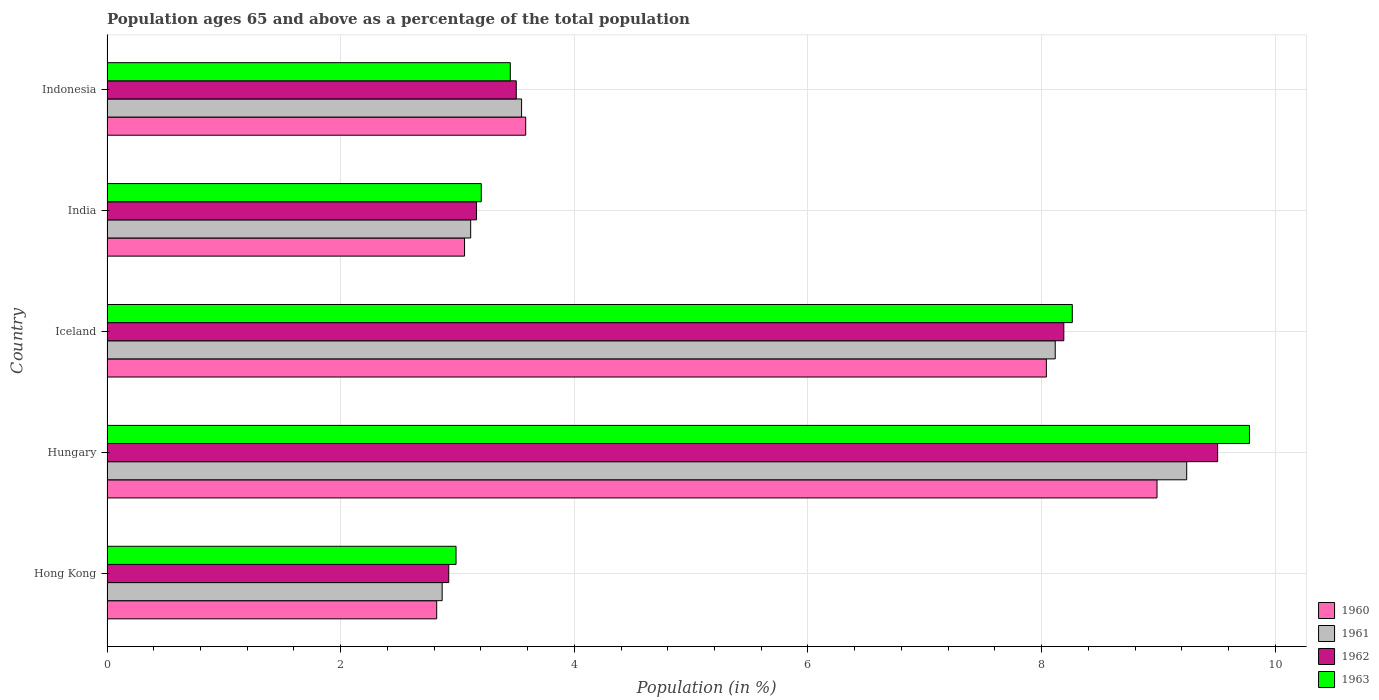How many different coloured bars are there?
Offer a very short reply. 4. How many groups of bars are there?
Your answer should be very brief. 5. Are the number of bars per tick equal to the number of legend labels?
Your answer should be compact. Yes. What is the label of the 5th group of bars from the top?
Offer a terse response. Hong Kong. What is the percentage of the population ages 65 and above in 1962 in India?
Your answer should be very brief. 3.16. Across all countries, what is the maximum percentage of the population ages 65 and above in 1961?
Provide a short and direct response. 9.24. Across all countries, what is the minimum percentage of the population ages 65 and above in 1962?
Give a very brief answer. 2.93. In which country was the percentage of the population ages 65 and above in 1960 maximum?
Make the answer very short. Hungary. In which country was the percentage of the population ages 65 and above in 1962 minimum?
Your answer should be very brief. Hong Kong. What is the total percentage of the population ages 65 and above in 1963 in the graph?
Your response must be concise. 27.69. What is the difference between the percentage of the population ages 65 and above in 1962 in Hong Kong and that in India?
Offer a very short reply. -0.24. What is the difference between the percentage of the population ages 65 and above in 1961 in India and the percentage of the population ages 65 and above in 1963 in Hungary?
Your response must be concise. -6.67. What is the average percentage of the population ages 65 and above in 1963 per country?
Make the answer very short. 5.54. What is the difference between the percentage of the population ages 65 and above in 1963 and percentage of the population ages 65 and above in 1962 in Iceland?
Make the answer very short. 0.07. In how many countries, is the percentage of the population ages 65 and above in 1962 greater than 5.6 ?
Your answer should be compact. 2. What is the ratio of the percentage of the population ages 65 and above in 1962 in Iceland to that in Indonesia?
Ensure brevity in your answer.  2.34. What is the difference between the highest and the second highest percentage of the population ages 65 and above in 1963?
Provide a succinct answer. 1.52. What is the difference between the highest and the lowest percentage of the population ages 65 and above in 1960?
Your answer should be compact. 6.17. In how many countries, is the percentage of the population ages 65 and above in 1962 greater than the average percentage of the population ages 65 and above in 1962 taken over all countries?
Provide a short and direct response. 2. How many bars are there?
Ensure brevity in your answer.  20. Are all the bars in the graph horizontal?
Give a very brief answer. Yes. How many countries are there in the graph?
Your answer should be very brief. 5. What is the difference between two consecutive major ticks on the X-axis?
Give a very brief answer. 2. Are the values on the major ticks of X-axis written in scientific E-notation?
Keep it short and to the point. No. Where does the legend appear in the graph?
Provide a succinct answer. Bottom right. How many legend labels are there?
Ensure brevity in your answer.  4. What is the title of the graph?
Give a very brief answer. Population ages 65 and above as a percentage of the total population. Does "1985" appear as one of the legend labels in the graph?
Provide a short and direct response. No. What is the label or title of the X-axis?
Keep it short and to the point. Population (in %). What is the Population (in %) in 1960 in Hong Kong?
Your answer should be very brief. 2.82. What is the Population (in %) of 1961 in Hong Kong?
Provide a succinct answer. 2.87. What is the Population (in %) in 1962 in Hong Kong?
Offer a very short reply. 2.93. What is the Population (in %) of 1963 in Hong Kong?
Offer a very short reply. 2.99. What is the Population (in %) of 1960 in Hungary?
Provide a short and direct response. 8.99. What is the Population (in %) in 1961 in Hungary?
Offer a very short reply. 9.24. What is the Population (in %) in 1962 in Hungary?
Ensure brevity in your answer.  9.51. What is the Population (in %) in 1963 in Hungary?
Your response must be concise. 9.78. What is the Population (in %) in 1960 in Iceland?
Provide a succinct answer. 8.04. What is the Population (in %) in 1961 in Iceland?
Ensure brevity in your answer.  8.12. What is the Population (in %) in 1962 in Iceland?
Provide a succinct answer. 8.19. What is the Population (in %) of 1963 in Iceland?
Offer a terse response. 8.26. What is the Population (in %) of 1960 in India?
Provide a short and direct response. 3.06. What is the Population (in %) of 1961 in India?
Give a very brief answer. 3.11. What is the Population (in %) in 1962 in India?
Your answer should be very brief. 3.16. What is the Population (in %) of 1963 in India?
Offer a very short reply. 3.2. What is the Population (in %) of 1960 in Indonesia?
Your response must be concise. 3.58. What is the Population (in %) in 1961 in Indonesia?
Offer a terse response. 3.55. What is the Population (in %) of 1962 in Indonesia?
Provide a succinct answer. 3.5. What is the Population (in %) of 1963 in Indonesia?
Offer a very short reply. 3.45. Across all countries, what is the maximum Population (in %) of 1960?
Offer a very short reply. 8.99. Across all countries, what is the maximum Population (in %) of 1961?
Provide a succinct answer. 9.24. Across all countries, what is the maximum Population (in %) in 1962?
Keep it short and to the point. 9.51. Across all countries, what is the maximum Population (in %) of 1963?
Give a very brief answer. 9.78. Across all countries, what is the minimum Population (in %) in 1960?
Your response must be concise. 2.82. Across all countries, what is the minimum Population (in %) in 1961?
Provide a succinct answer. 2.87. Across all countries, what is the minimum Population (in %) in 1962?
Offer a very short reply. 2.93. Across all countries, what is the minimum Population (in %) of 1963?
Offer a very short reply. 2.99. What is the total Population (in %) of 1960 in the graph?
Offer a very short reply. 26.5. What is the total Population (in %) in 1961 in the graph?
Provide a short and direct response. 26.89. What is the total Population (in %) in 1962 in the graph?
Offer a very short reply. 27.29. What is the total Population (in %) in 1963 in the graph?
Offer a very short reply. 27.69. What is the difference between the Population (in %) in 1960 in Hong Kong and that in Hungary?
Provide a succinct answer. -6.17. What is the difference between the Population (in %) in 1961 in Hong Kong and that in Hungary?
Your answer should be very brief. -6.37. What is the difference between the Population (in %) of 1962 in Hong Kong and that in Hungary?
Your response must be concise. -6.58. What is the difference between the Population (in %) of 1963 in Hong Kong and that in Hungary?
Offer a terse response. -6.79. What is the difference between the Population (in %) in 1960 in Hong Kong and that in Iceland?
Your response must be concise. -5.22. What is the difference between the Population (in %) in 1961 in Hong Kong and that in Iceland?
Ensure brevity in your answer.  -5.25. What is the difference between the Population (in %) of 1962 in Hong Kong and that in Iceland?
Your answer should be compact. -5.27. What is the difference between the Population (in %) in 1963 in Hong Kong and that in Iceland?
Your answer should be compact. -5.28. What is the difference between the Population (in %) in 1960 in Hong Kong and that in India?
Your answer should be very brief. -0.24. What is the difference between the Population (in %) of 1961 in Hong Kong and that in India?
Ensure brevity in your answer.  -0.24. What is the difference between the Population (in %) in 1962 in Hong Kong and that in India?
Your answer should be compact. -0.24. What is the difference between the Population (in %) of 1963 in Hong Kong and that in India?
Give a very brief answer. -0.22. What is the difference between the Population (in %) of 1960 in Hong Kong and that in Indonesia?
Offer a terse response. -0.76. What is the difference between the Population (in %) in 1961 in Hong Kong and that in Indonesia?
Offer a very short reply. -0.68. What is the difference between the Population (in %) of 1962 in Hong Kong and that in Indonesia?
Provide a short and direct response. -0.58. What is the difference between the Population (in %) in 1963 in Hong Kong and that in Indonesia?
Offer a very short reply. -0.46. What is the difference between the Population (in %) of 1960 in Hungary and that in Iceland?
Offer a very short reply. 0.95. What is the difference between the Population (in %) of 1961 in Hungary and that in Iceland?
Keep it short and to the point. 1.13. What is the difference between the Population (in %) in 1962 in Hungary and that in Iceland?
Your answer should be compact. 1.32. What is the difference between the Population (in %) in 1963 in Hungary and that in Iceland?
Offer a very short reply. 1.52. What is the difference between the Population (in %) in 1960 in Hungary and that in India?
Your response must be concise. 5.93. What is the difference between the Population (in %) of 1961 in Hungary and that in India?
Provide a short and direct response. 6.13. What is the difference between the Population (in %) of 1962 in Hungary and that in India?
Your response must be concise. 6.34. What is the difference between the Population (in %) of 1963 in Hungary and that in India?
Offer a terse response. 6.58. What is the difference between the Population (in %) in 1960 in Hungary and that in Indonesia?
Make the answer very short. 5.4. What is the difference between the Population (in %) in 1961 in Hungary and that in Indonesia?
Ensure brevity in your answer.  5.69. What is the difference between the Population (in %) of 1962 in Hungary and that in Indonesia?
Offer a terse response. 6. What is the difference between the Population (in %) in 1963 in Hungary and that in Indonesia?
Your answer should be very brief. 6.33. What is the difference between the Population (in %) of 1960 in Iceland and that in India?
Offer a very short reply. 4.98. What is the difference between the Population (in %) of 1961 in Iceland and that in India?
Give a very brief answer. 5. What is the difference between the Population (in %) in 1962 in Iceland and that in India?
Your response must be concise. 5.03. What is the difference between the Population (in %) of 1963 in Iceland and that in India?
Provide a short and direct response. 5.06. What is the difference between the Population (in %) of 1960 in Iceland and that in Indonesia?
Offer a terse response. 4.46. What is the difference between the Population (in %) in 1961 in Iceland and that in Indonesia?
Make the answer very short. 4.57. What is the difference between the Population (in %) in 1962 in Iceland and that in Indonesia?
Make the answer very short. 4.69. What is the difference between the Population (in %) in 1963 in Iceland and that in Indonesia?
Offer a terse response. 4.81. What is the difference between the Population (in %) in 1960 in India and that in Indonesia?
Provide a succinct answer. -0.52. What is the difference between the Population (in %) of 1961 in India and that in Indonesia?
Keep it short and to the point. -0.44. What is the difference between the Population (in %) of 1962 in India and that in Indonesia?
Keep it short and to the point. -0.34. What is the difference between the Population (in %) of 1963 in India and that in Indonesia?
Provide a succinct answer. -0.25. What is the difference between the Population (in %) in 1960 in Hong Kong and the Population (in %) in 1961 in Hungary?
Your answer should be very brief. -6.42. What is the difference between the Population (in %) in 1960 in Hong Kong and the Population (in %) in 1962 in Hungary?
Provide a succinct answer. -6.69. What is the difference between the Population (in %) of 1960 in Hong Kong and the Population (in %) of 1963 in Hungary?
Give a very brief answer. -6.96. What is the difference between the Population (in %) in 1961 in Hong Kong and the Population (in %) in 1962 in Hungary?
Give a very brief answer. -6.64. What is the difference between the Population (in %) in 1961 in Hong Kong and the Population (in %) in 1963 in Hungary?
Your answer should be very brief. -6.91. What is the difference between the Population (in %) in 1962 in Hong Kong and the Population (in %) in 1963 in Hungary?
Keep it short and to the point. -6.85. What is the difference between the Population (in %) of 1960 in Hong Kong and the Population (in %) of 1961 in Iceland?
Ensure brevity in your answer.  -5.29. What is the difference between the Population (in %) of 1960 in Hong Kong and the Population (in %) of 1962 in Iceland?
Keep it short and to the point. -5.37. What is the difference between the Population (in %) in 1960 in Hong Kong and the Population (in %) in 1963 in Iceland?
Provide a short and direct response. -5.44. What is the difference between the Population (in %) in 1961 in Hong Kong and the Population (in %) in 1962 in Iceland?
Your answer should be compact. -5.32. What is the difference between the Population (in %) in 1961 in Hong Kong and the Population (in %) in 1963 in Iceland?
Offer a very short reply. -5.39. What is the difference between the Population (in %) in 1962 in Hong Kong and the Population (in %) in 1963 in Iceland?
Give a very brief answer. -5.34. What is the difference between the Population (in %) in 1960 in Hong Kong and the Population (in %) in 1961 in India?
Make the answer very short. -0.29. What is the difference between the Population (in %) in 1960 in Hong Kong and the Population (in %) in 1962 in India?
Offer a terse response. -0.34. What is the difference between the Population (in %) in 1960 in Hong Kong and the Population (in %) in 1963 in India?
Offer a very short reply. -0.38. What is the difference between the Population (in %) in 1961 in Hong Kong and the Population (in %) in 1962 in India?
Provide a short and direct response. -0.29. What is the difference between the Population (in %) of 1961 in Hong Kong and the Population (in %) of 1963 in India?
Make the answer very short. -0.33. What is the difference between the Population (in %) in 1962 in Hong Kong and the Population (in %) in 1963 in India?
Provide a short and direct response. -0.28. What is the difference between the Population (in %) of 1960 in Hong Kong and the Population (in %) of 1961 in Indonesia?
Provide a succinct answer. -0.73. What is the difference between the Population (in %) in 1960 in Hong Kong and the Population (in %) in 1962 in Indonesia?
Provide a short and direct response. -0.68. What is the difference between the Population (in %) of 1960 in Hong Kong and the Population (in %) of 1963 in Indonesia?
Offer a terse response. -0.63. What is the difference between the Population (in %) of 1961 in Hong Kong and the Population (in %) of 1962 in Indonesia?
Your answer should be very brief. -0.63. What is the difference between the Population (in %) in 1961 in Hong Kong and the Population (in %) in 1963 in Indonesia?
Offer a very short reply. -0.58. What is the difference between the Population (in %) of 1962 in Hong Kong and the Population (in %) of 1963 in Indonesia?
Your answer should be very brief. -0.53. What is the difference between the Population (in %) in 1960 in Hungary and the Population (in %) in 1961 in Iceland?
Offer a very short reply. 0.87. What is the difference between the Population (in %) of 1960 in Hungary and the Population (in %) of 1962 in Iceland?
Offer a very short reply. 0.8. What is the difference between the Population (in %) of 1960 in Hungary and the Population (in %) of 1963 in Iceland?
Make the answer very short. 0.73. What is the difference between the Population (in %) in 1961 in Hungary and the Population (in %) in 1962 in Iceland?
Your response must be concise. 1.05. What is the difference between the Population (in %) in 1961 in Hungary and the Population (in %) in 1963 in Iceland?
Give a very brief answer. 0.98. What is the difference between the Population (in %) in 1962 in Hungary and the Population (in %) in 1963 in Iceland?
Your answer should be compact. 1.24. What is the difference between the Population (in %) in 1960 in Hungary and the Population (in %) in 1961 in India?
Provide a succinct answer. 5.88. What is the difference between the Population (in %) of 1960 in Hungary and the Population (in %) of 1962 in India?
Keep it short and to the point. 5.83. What is the difference between the Population (in %) in 1960 in Hungary and the Population (in %) in 1963 in India?
Make the answer very short. 5.78. What is the difference between the Population (in %) of 1961 in Hungary and the Population (in %) of 1962 in India?
Make the answer very short. 6.08. What is the difference between the Population (in %) in 1961 in Hungary and the Population (in %) in 1963 in India?
Your response must be concise. 6.04. What is the difference between the Population (in %) in 1962 in Hungary and the Population (in %) in 1963 in India?
Ensure brevity in your answer.  6.3. What is the difference between the Population (in %) in 1960 in Hungary and the Population (in %) in 1961 in Indonesia?
Your answer should be compact. 5.44. What is the difference between the Population (in %) of 1960 in Hungary and the Population (in %) of 1962 in Indonesia?
Ensure brevity in your answer.  5.48. What is the difference between the Population (in %) in 1960 in Hungary and the Population (in %) in 1963 in Indonesia?
Your answer should be compact. 5.54. What is the difference between the Population (in %) of 1961 in Hungary and the Population (in %) of 1962 in Indonesia?
Give a very brief answer. 5.74. What is the difference between the Population (in %) in 1961 in Hungary and the Population (in %) in 1963 in Indonesia?
Provide a short and direct response. 5.79. What is the difference between the Population (in %) of 1962 in Hungary and the Population (in %) of 1963 in Indonesia?
Ensure brevity in your answer.  6.06. What is the difference between the Population (in %) of 1960 in Iceland and the Population (in %) of 1961 in India?
Your response must be concise. 4.93. What is the difference between the Population (in %) of 1960 in Iceland and the Population (in %) of 1962 in India?
Your response must be concise. 4.88. What is the difference between the Population (in %) in 1960 in Iceland and the Population (in %) in 1963 in India?
Your response must be concise. 4.84. What is the difference between the Population (in %) in 1961 in Iceland and the Population (in %) in 1962 in India?
Make the answer very short. 4.95. What is the difference between the Population (in %) of 1961 in Iceland and the Population (in %) of 1963 in India?
Keep it short and to the point. 4.91. What is the difference between the Population (in %) in 1962 in Iceland and the Population (in %) in 1963 in India?
Keep it short and to the point. 4.99. What is the difference between the Population (in %) of 1960 in Iceland and the Population (in %) of 1961 in Indonesia?
Provide a short and direct response. 4.49. What is the difference between the Population (in %) of 1960 in Iceland and the Population (in %) of 1962 in Indonesia?
Your response must be concise. 4.54. What is the difference between the Population (in %) in 1960 in Iceland and the Population (in %) in 1963 in Indonesia?
Make the answer very short. 4.59. What is the difference between the Population (in %) of 1961 in Iceland and the Population (in %) of 1962 in Indonesia?
Offer a very short reply. 4.61. What is the difference between the Population (in %) of 1961 in Iceland and the Population (in %) of 1963 in Indonesia?
Your response must be concise. 4.66. What is the difference between the Population (in %) in 1962 in Iceland and the Population (in %) in 1963 in Indonesia?
Give a very brief answer. 4.74. What is the difference between the Population (in %) in 1960 in India and the Population (in %) in 1961 in Indonesia?
Give a very brief answer. -0.49. What is the difference between the Population (in %) of 1960 in India and the Population (in %) of 1962 in Indonesia?
Keep it short and to the point. -0.44. What is the difference between the Population (in %) of 1960 in India and the Population (in %) of 1963 in Indonesia?
Keep it short and to the point. -0.39. What is the difference between the Population (in %) of 1961 in India and the Population (in %) of 1962 in Indonesia?
Offer a terse response. -0.39. What is the difference between the Population (in %) in 1961 in India and the Population (in %) in 1963 in Indonesia?
Your answer should be very brief. -0.34. What is the difference between the Population (in %) of 1962 in India and the Population (in %) of 1963 in Indonesia?
Offer a very short reply. -0.29. What is the average Population (in %) in 1960 per country?
Give a very brief answer. 5.3. What is the average Population (in %) of 1961 per country?
Make the answer very short. 5.38. What is the average Population (in %) in 1962 per country?
Keep it short and to the point. 5.46. What is the average Population (in %) in 1963 per country?
Offer a terse response. 5.54. What is the difference between the Population (in %) in 1960 and Population (in %) in 1961 in Hong Kong?
Provide a short and direct response. -0.05. What is the difference between the Population (in %) in 1960 and Population (in %) in 1962 in Hong Kong?
Give a very brief answer. -0.1. What is the difference between the Population (in %) in 1960 and Population (in %) in 1963 in Hong Kong?
Your answer should be very brief. -0.17. What is the difference between the Population (in %) of 1961 and Population (in %) of 1962 in Hong Kong?
Keep it short and to the point. -0.06. What is the difference between the Population (in %) in 1961 and Population (in %) in 1963 in Hong Kong?
Make the answer very short. -0.12. What is the difference between the Population (in %) of 1962 and Population (in %) of 1963 in Hong Kong?
Keep it short and to the point. -0.06. What is the difference between the Population (in %) in 1960 and Population (in %) in 1961 in Hungary?
Your response must be concise. -0.25. What is the difference between the Population (in %) in 1960 and Population (in %) in 1962 in Hungary?
Keep it short and to the point. -0.52. What is the difference between the Population (in %) in 1960 and Population (in %) in 1963 in Hungary?
Provide a succinct answer. -0.79. What is the difference between the Population (in %) in 1961 and Population (in %) in 1962 in Hungary?
Ensure brevity in your answer.  -0.26. What is the difference between the Population (in %) of 1961 and Population (in %) of 1963 in Hungary?
Your response must be concise. -0.54. What is the difference between the Population (in %) in 1962 and Population (in %) in 1963 in Hungary?
Make the answer very short. -0.27. What is the difference between the Population (in %) of 1960 and Population (in %) of 1961 in Iceland?
Give a very brief answer. -0.08. What is the difference between the Population (in %) in 1960 and Population (in %) in 1962 in Iceland?
Provide a short and direct response. -0.15. What is the difference between the Population (in %) of 1960 and Population (in %) of 1963 in Iceland?
Ensure brevity in your answer.  -0.22. What is the difference between the Population (in %) of 1961 and Population (in %) of 1962 in Iceland?
Your answer should be compact. -0.07. What is the difference between the Population (in %) in 1961 and Population (in %) in 1963 in Iceland?
Make the answer very short. -0.15. What is the difference between the Population (in %) in 1962 and Population (in %) in 1963 in Iceland?
Give a very brief answer. -0.07. What is the difference between the Population (in %) of 1960 and Population (in %) of 1961 in India?
Provide a short and direct response. -0.05. What is the difference between the Population (in %) in 1960 and Population (in %) in 1962 in India?
Give a very brief answer. -0.1. What is the difference between the Population (in %) of 1960 and Population (in %) of 1963 in India?
Your response must be concise. -0.14. What is the difference between the Population (in %) of 1961 and Population (in %) of 1962 in India?
Your answer should be compact. -0.05. What is the difference between the Population (in %) of 1961 and Population (in %) of 1963 in India?
Offer a terse response. -0.09. What is the difference between the Population (in %) in 1962 and Population (in %) in 1963 in India?
Provide a short and direct response. -0.04. What is the difference between the Population (in %) in 1960 and Population (in %) in 1961 in Indonesia?
Your answer should be compact. 0.04. What is the difference between the Population (in %) in 1960 and Population (in %) in 1962 in Indonesia?
Keep it short and to the point. 0.08. What is the difference between the Population (in %) in 1960 and Population (in %) in 1963 in Indonesia?
Provide a succinct answer. 0.13. What is the difference between the Population (in %) of 1961 and Population (in %) of 1962 in Indonesia?
Your response must be concise. 0.05. What is the difference between the Population (in %) of 1961 and Population (in %) of 1963 in Indonesia?
Provide a succinct answer. 0.1. What is the difference between the Population (in %) of 1962 and Population (in %) of 1963 in Indonesia?
Your answer should be very brief. 0.05. What is the ratio of the Population (in %) in 1960 in Hong Kong to that in Hungary?
Make the answer very short. 0.31. What is the ratio of the Population (in %) in 1961 in Hong Kong to that in Hungary?
Provide a short and direct response. 0.31. What is the ratio of the Population (in %) in 1962 in Hong Kong to that in Hungary?
Keep it short and to the point. 0.31. What is the ratio of the Population (in %) of 1963 in Hong Kong to that in Hungary?
Offer a terse response. 0.31. What is the ratio of the Population (in %) in 1960 in Hong Kong to that in Iceland?
Your answer should be compact. 0.35. What is the ratio of the Population (in %) in 1961 in Hong Kong to that in Iceland?
Your response must be concise. 0.35. What is the ratio of the Population (in %) in 1962 in Hong Kong to that in Iceland?
Keep it short and to the point. 0.36. What is the ratio of the Population (in %) in 1963 in Hong Kong to that in Iceland?
Give a very brief answer. 0.36. What is the ratio of the Population (in %) in 1960 in Hong Kong to that in India?
Ensure brevity in your answer.  0.92. What is the ratio of the Population (in %) of 1961 in Hong Kong to that in India?
Offer a very short reply. 0.92. What is the ratio of the Population (in %) in 1962 in Hong Kong to that in India?
Make the answer very short. 0.92. What is the ratio of the Population (in %) in 1963 in Hong Kong to that in India?
Make the answer very short. 0.93. What is the ratio of the Population (in %) in 1960 in Hong Kong to that in Indonesia?
Your answer should be very brief. 0.79. What is the ratio of the Population (in %) of 1961 in Hong Kong to that in Indonesia?
Your answer should be compact. 0.81. What is the ratio of the Population (in %) of 1962 in Hong Kong to that in Indonesia?
Your answer should be very brief. 0.83. What is the ratio of the Population (in %) in 1963 in Hong Kong to that in Indonesia?
Give a very brief answer. 0.87. What is the ratio of the Population (in %) in 1960 in Hungary to that in Iceland?
Provide a succinct answer. 1.12. What is the ratio of the Population (in %) in 1961 in Hungary to that in Iceland?
Your answer should be very brief. 1.14. What is the ratio of the Population (in %) in 1962 in Hungary to that in Iceland?
Your response must be concise. 1.16. What is the ratio of the Population (in %) of 1963 in Hungary to that in Iceland?
Your response must be concise. 1.18. What is the ratio of the Population (in %) of 1960 in Hungary to that in India?
Your response must be concise. 2.94. What is the ratio of the Population (in %) of 1961 in Hungary to that in India?
Your answer should be compact. 2.97. What is the ratio of the Population (in %) of 1962 in Hungary to that in India?
Your answer should be very brief. 3.01. What is the ratio of the Population (in %) in 1963 in Hungary to that in India?
Your response must be concise. 3.05. What is the ratio of the Population (in %) of 1960 in Hungary to that in Indonesia?
Give a very brief answer. 2.51. What is the ratio of the Population (in %) in 1961 in Hungary to that in Indonesia?
Provide a short and direct response. 2.6. What is the ratio of the Population (in %) in 1962 in Hungary to that in Indonesia?
Your response must be concise. 2.71. What is the ratio of the Population (in %) in 1963 in Hungary to that in Indonesia?
Keep it short and to the point. 2.83. What is the ratio of the Population (in %) in 1960 in Iceland to that in India?
Your response must be concise. 2.63. What is the ratio of the Population (in %) in 1961 in Iceland to that in India?
Ensure brevity in your answer.  2.61. What is the ratio of the Population (in %) of 1962 in Iceland to that in India?
Your answer should be very brief. 2.59. What is the ratio of the Population (in %) of 1963 in Iceland to that in India?
Your response must be concise. 2.58. What is the ratio of the Population (in %) of 1960 in Iceland to that in Indonesia?
Ensure brevity in your answer.  2.24. What is the ratio of the Population (in %) in 1961 in Iceland to that in Indonesia?
Your answer should be very brief. 2.29. What is the ratio of the Population (in %) in 1962 in Iceland to that in Indonesia?
Offer a very short reply. 2.34. What is the ratio of the Population (in %) of 1963 in Iceland to that in Indonesia?
Provide a succinct answer. 2.39. What is the ratio of the Population (in %) of 1960 in India to that in Indonesia?
Keep it short and to the point. 0.85. What is the ratio of the Population (in %) of 1961 in India to that in Indonesia?
Provide a succinct answer. 0.88. What is the ratio of the Population (in %) of 1962 in India to that in Indonesia?
Give a very brief answer. 0.9. What is the ratio of the Population (in %) of 1963 in India to that in Indonesia?
Offer a terse response. 0.93. What is the difference between the highest and the second highest Population (in %) in 1960?
Your answer should be very brief. 0.95. What is the difference between the highest and the second highest Population (in %) in 1961?
Offer a very short reply. 1.13. What is the difference between the highest and the second highest Population (in %) in 1962?
Offer a very short reply. 1.32. What is the difference between the highest and the second highest Population (in %) of 1963?
Make the answer very short. 1.52. What is the difference between the highest and the lowest Population (in %) in 1960?
Provide a short and direct response. 6.17. What is the difference between the highest and the lowest Population (in %) of 1961?
Make the answer very short. 6.37. What is the difference between the highest and the lowest Population (in %) in 1962?
Provide a succinct answer. 6.58. What is the difference between the highest and the lowest Population (in %) of 1963?
Offer a very short reply. 6.79. 